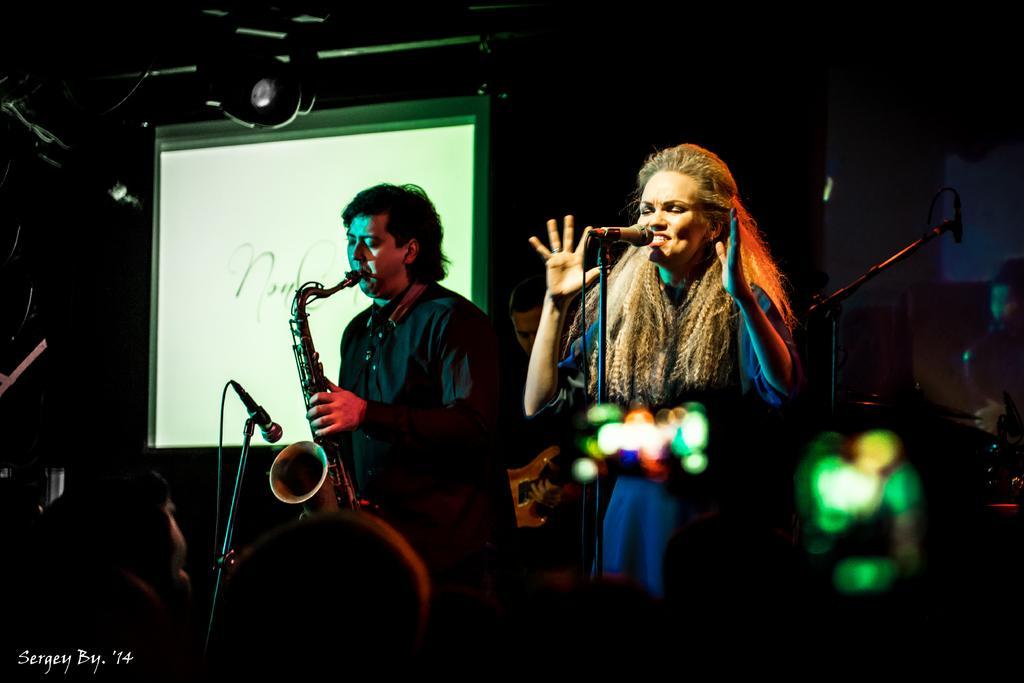In one or two sentences, can you explain what this image depicts? In this image I can see two people with different color dresses and one person playing the musical instrument. In-front of these people I can see the mice and few more people. I can see the screen and the black background. 